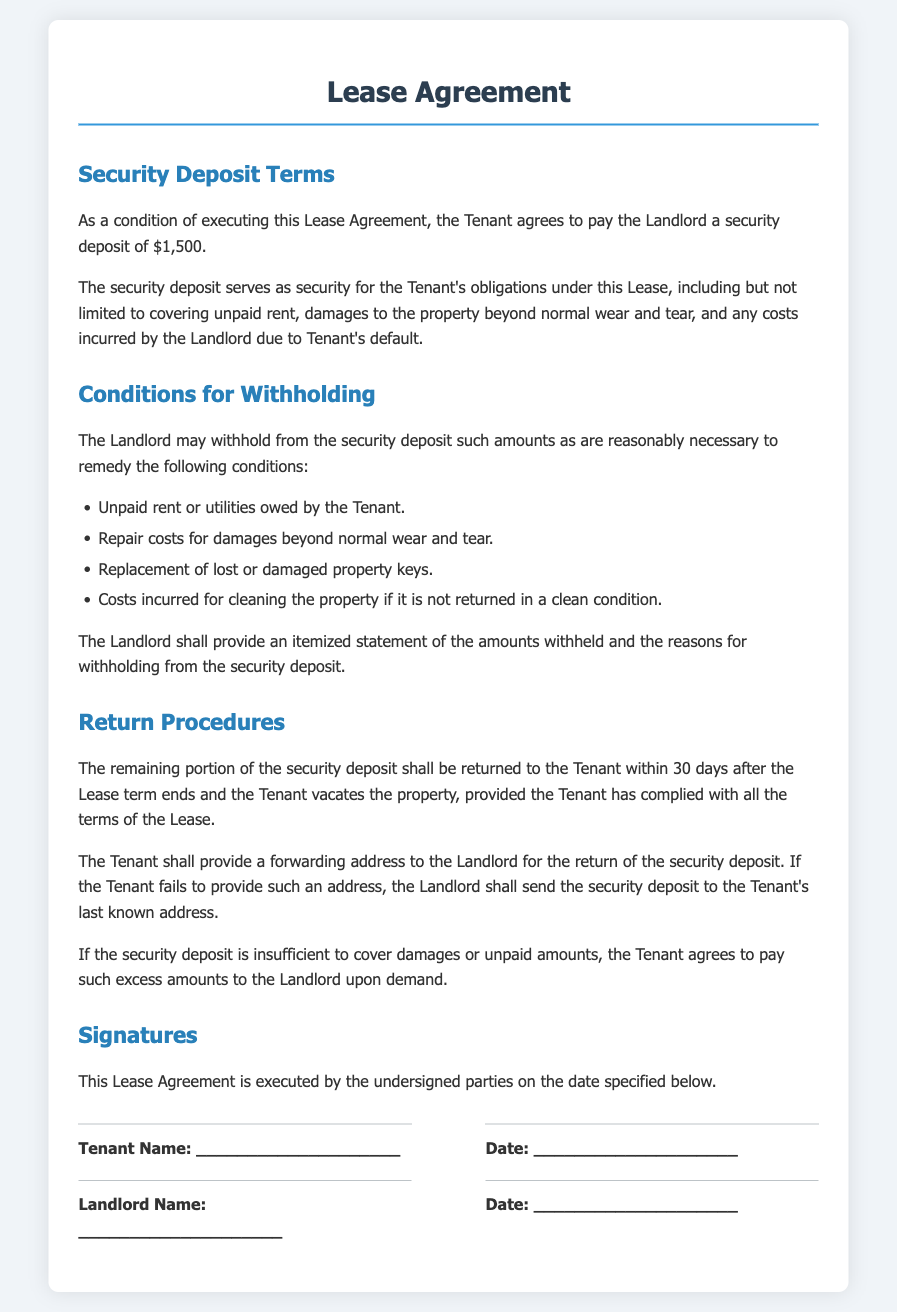What is the amount of the security deposit? The security deposit amount is explicitly stated in the document as $1,500.
Answer: $1,500 What can the security deposit be used for? The document lists multiple uses, including unpaid rent, damages, lost keys, and cleaning costs.
Answer: Unpaid rent, damages, lost keys, cleaning costs How long does the Landlord have to return the security deposit? The document specifies that the return must occur within 30 days after the Lease term ends.
Answer: 30 days What must the Tenant provide to the Landlord for the return of the security deposit? The document states the Tenant must provide a forwarding address for the return.
Answer: Forwarding address What happens if the security deposit does not cover damages? The document indicates that the Tenant agrees to pay any excess amounts to the Landlord upon demand.
Answer: Pay excess amounts Which costs may be withheld from the security deposit? The document lists specific conditions under which withholding is allowed, including unpaid rent and repair costs.
Answer: Unpaid rent, repair costs What should be included in the itemized statement provided by the Landlord? The document mentions that the statement must include amounts withheld and reasons for withholding.
Answer: Amounts withheld, reasons for withholding What is the significance of the security deposit in the Lease Agreement? The security deposit serves as security for the Tenant's obligations under the Lease.
Answer: Security for obligations 